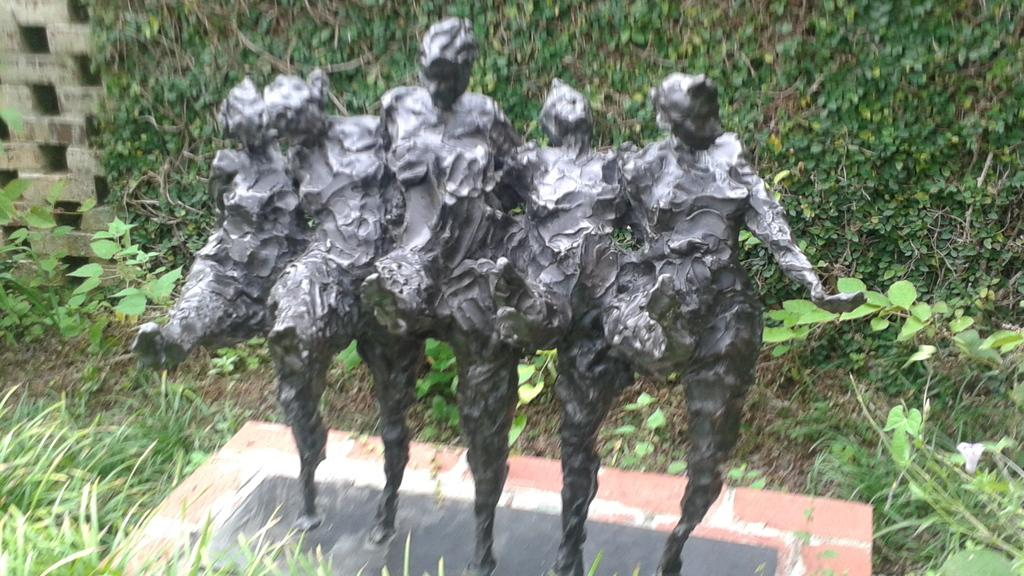What type of art is present in the image? There are sculptures in the image. What type of vegetation is on the right side of the image? There is grass and plants on the right side of the image. What type of structure is on the left side of the image? There is a wall on the left side of the image. What type of vegetation is on the left side of the image? There are many plants on the left side of the image. How many songs are being sung by the girls in the image? There are no girls or songs present in the image; it features sculptures, grass, plants, and a wall. What type of island can be seen in the image? There is no island present in the image. 